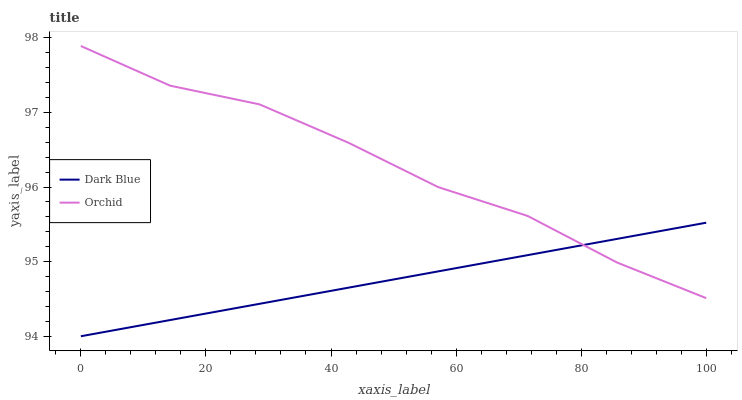Does Dark Blue have the minimum area under the curve?
Answer yes or no. Yes. Does Orchid have the maximum area under the curve?
Answer yes or no. Yes. Does Orchid have the minimum area under the curve?
Answer yes or no. No. Is Dark Blue the smoothest?
Answer yes or no. Yes. Is Orchid the roughest?
Answer yes or no. Yes. Is Orchid the smoothest?
Answer yes or no. No. Does Dark Blue have the lowest value?
Answer yes or no. Yes. Does Orchid have the lowest value?
Answer yes or no. No. Does Orchid have the highest value?
Answer yes or no. Yes. Does Orchid intersect Dark Blue?
Answer yes or no. Yes. Is Orchid less than Dark Blue?
Answer yes or no. No. Is Orchid greater than Dark Blue?
Answer yes or no. No. 